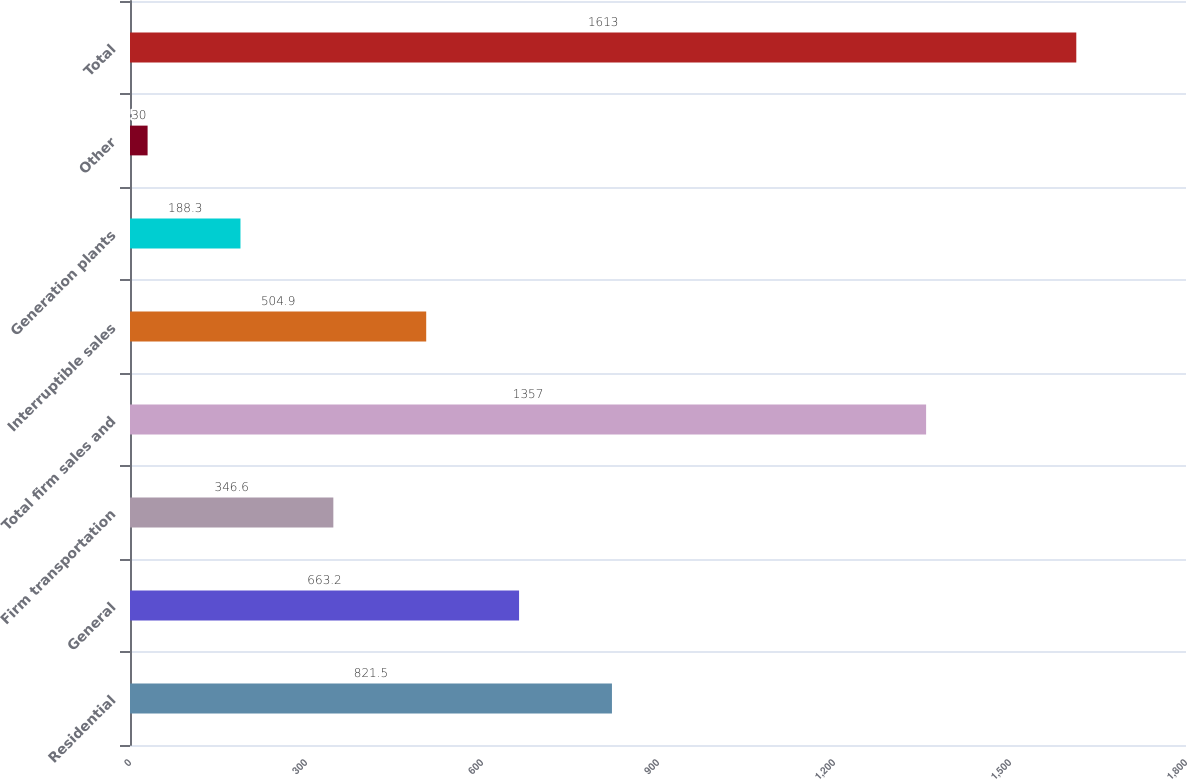Convert chart to OTSL. <chart><loc_0><loc_0><loc_500><loc_500><bar_chart><fcel>Residential<fcel>General<fcel>Firm transportation<fcel>Total firm sales and<fcel>Interruptible sales<fcel>Generation plants<fcel>Other<fcel>Total<nl><fcel>821.5<fcel>663.2<fcel>346.6<fcel>1357<fcel>504.9<fcel>188.3<fcel>30<fcel>1613<nl></chart> 